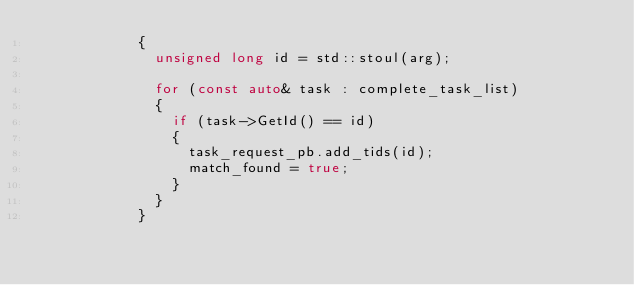<code> <loc_0><loc_0><loc_500><loc_500><_C++_>            {
              unsigned long id = std::stoul(arg);

              for (const auto& task : complete_task_list)
              {
                if (task->GetId() == id)
                {
                  task_request_pb.add_tids(id);
                  match_found = true;
                }
              }
            }</code> 